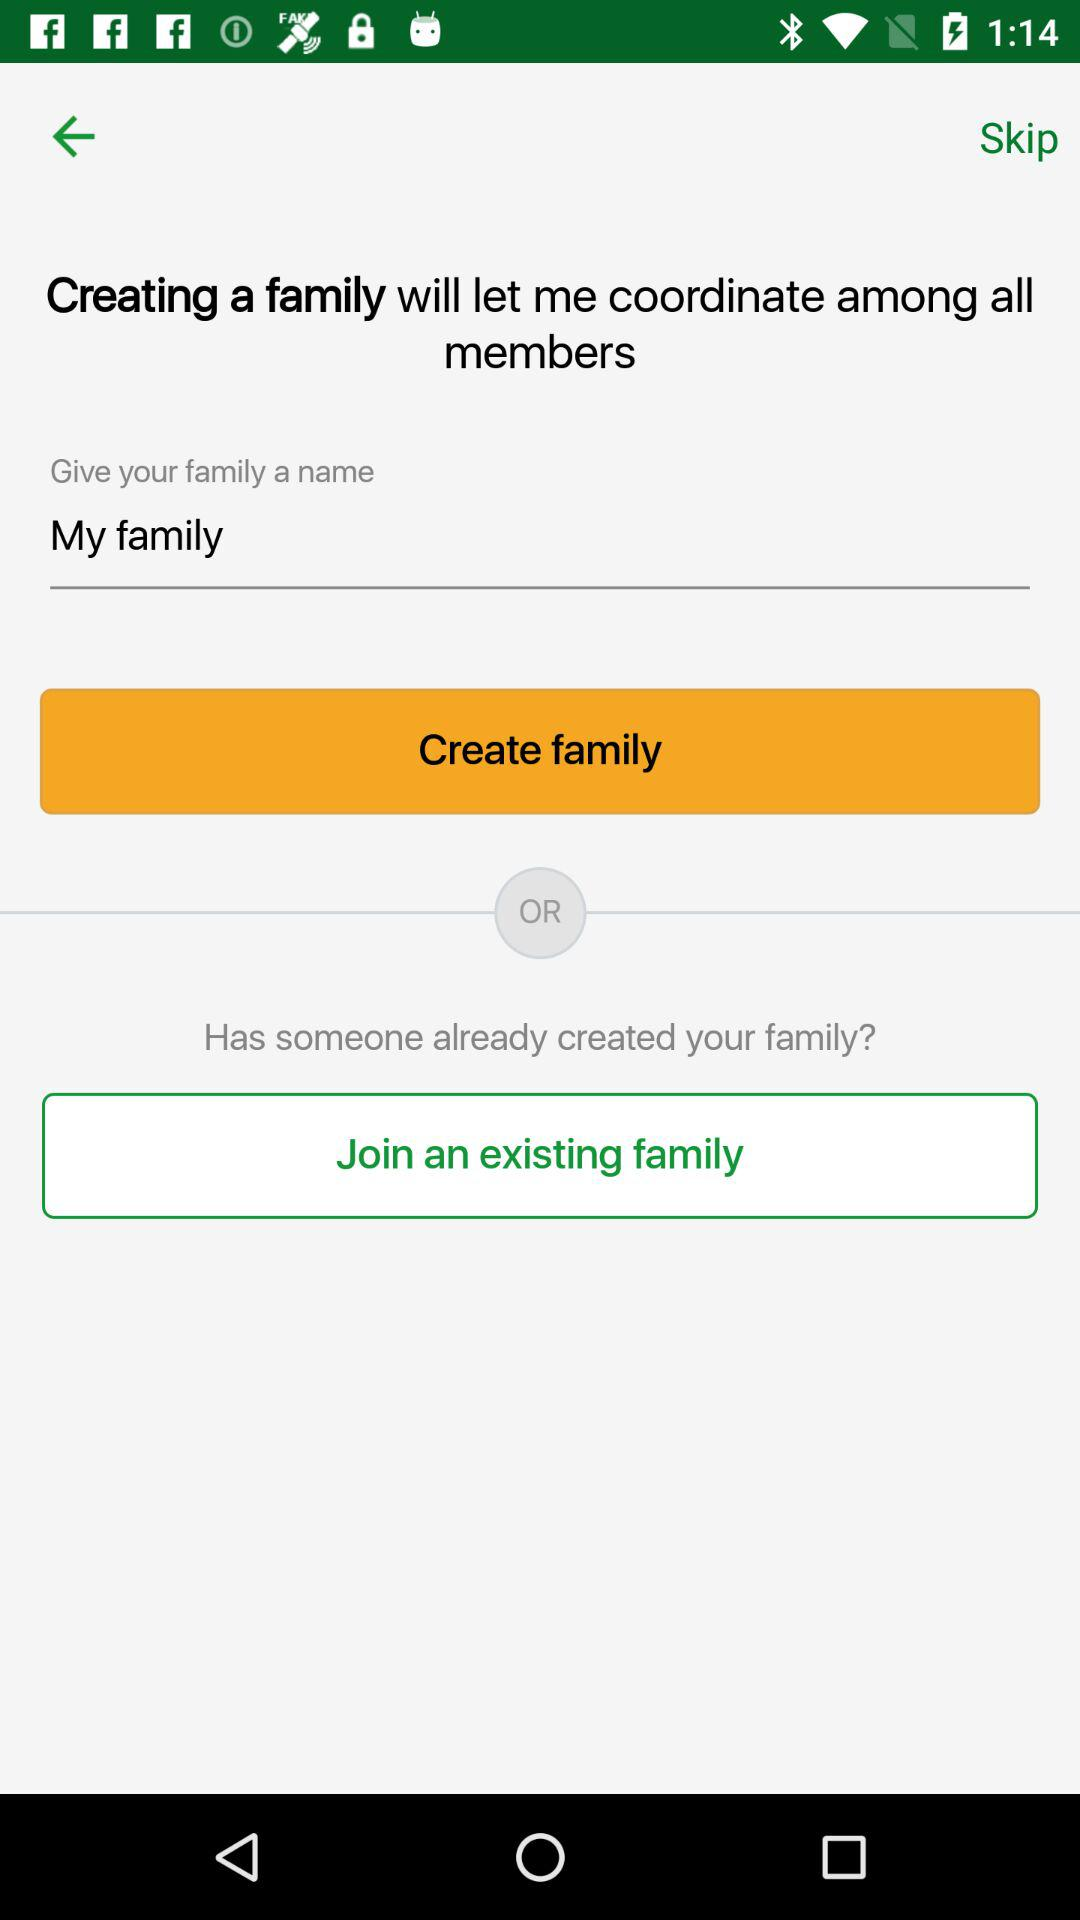What is the entered name? The entered name is "My family". 